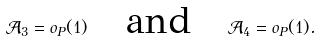Convert formula to latex. <formula><loc_0><loc_0><loc_500><loc_500>\mathcal { A } _ { 3 } = o _ { P } ( 1 ) \quad \text {and} \quad \mathcal { A } _ { 4 } = o _ { P } ( 1 ) .</formula> 